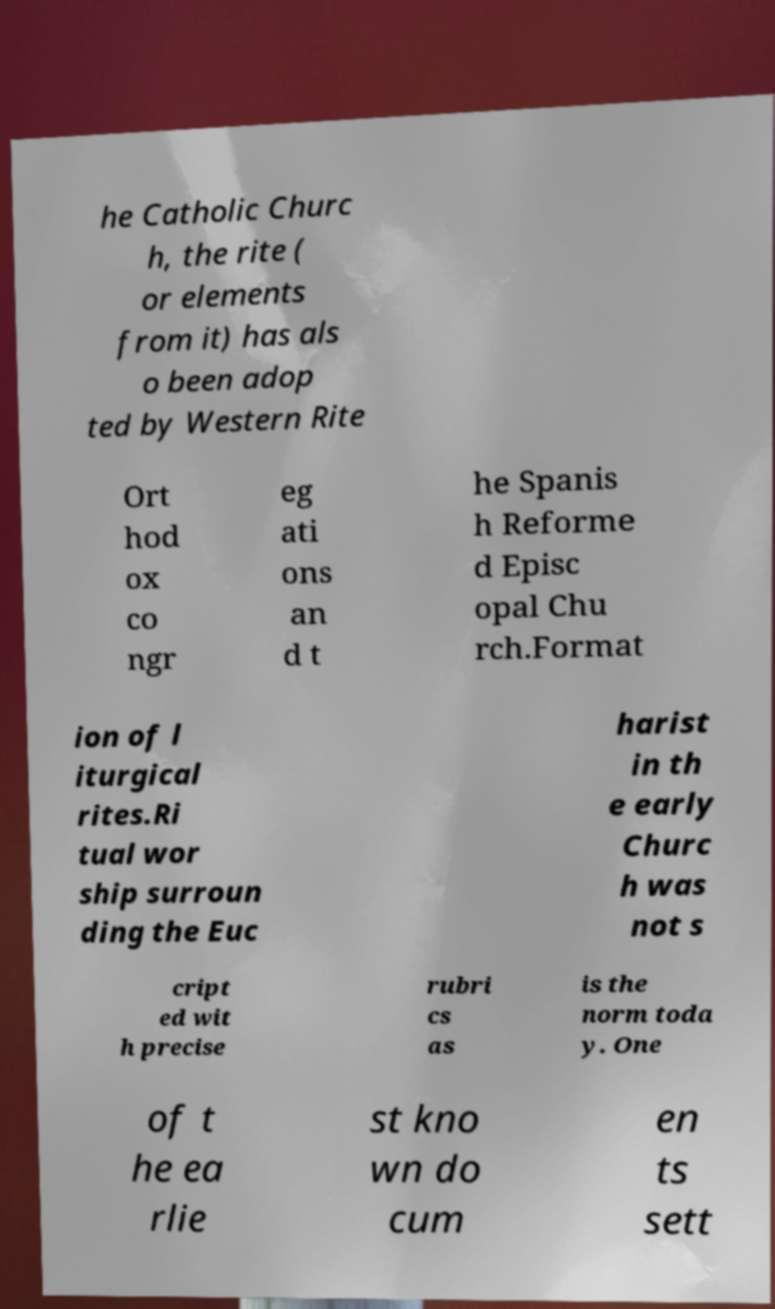Could you assist in decoding the text presented in this image and type it out clearly? he Catholic Churc h, the rite ( or elements from it) has als o been adop ted by Western Rite Ort hod ox co ngr eg ati ons an d t he Spanis h Reforme d Episc opal Chu rch.Format ion of l iturgical rites.Ri tual wor ship surroun ding the Euc harist in th e early Churc h was not s cript ed wit h precise rubri cs as is the norm toda y. One of t he ea rlie st kno wn do cum en ts sett 